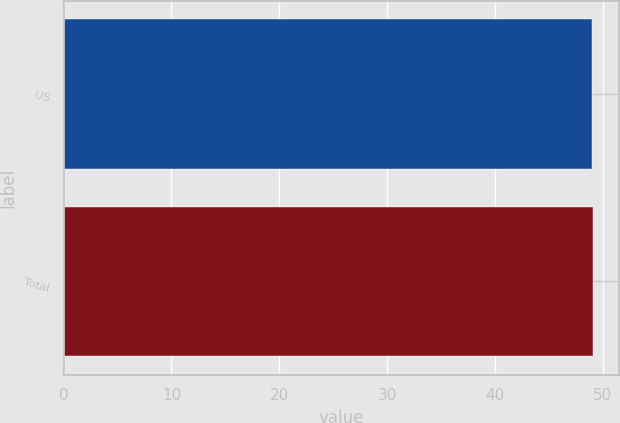<chart> <loc_0><loc_0><loc_500><loc_500><bar_chart><fcel>US<fcel>Total<nl><fcel>49<fcel>49.1<nl></chart> 